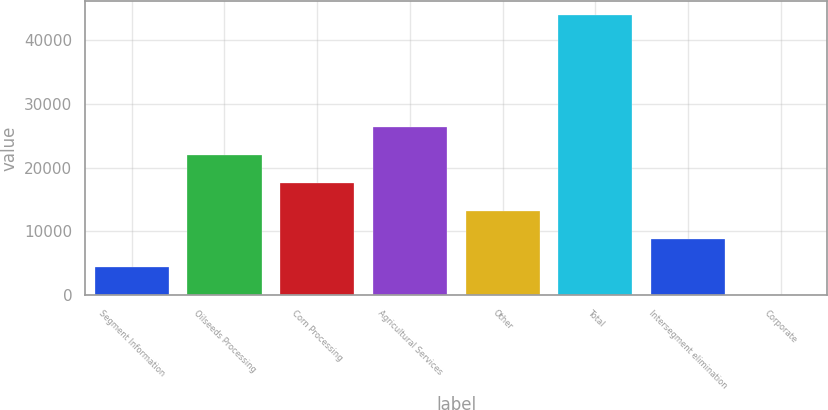<chart> <loc_0><loc_0><loc_500><loc_500><bar_chart><fcel>Segment Information<fcel>Oilseeds Processing<fcel>Corn Processing<fcel>Agricultural Services<fcel>Other<fcel>Total<fcel>Intersegment elimination<fcel>Corporate<nl><fcel>4422.5<fcel>22020.5<fcel>17621<fcel>26420<fcel>13221.5<fcel>44018<fcel>8822<fcel>23<nl></chart> 